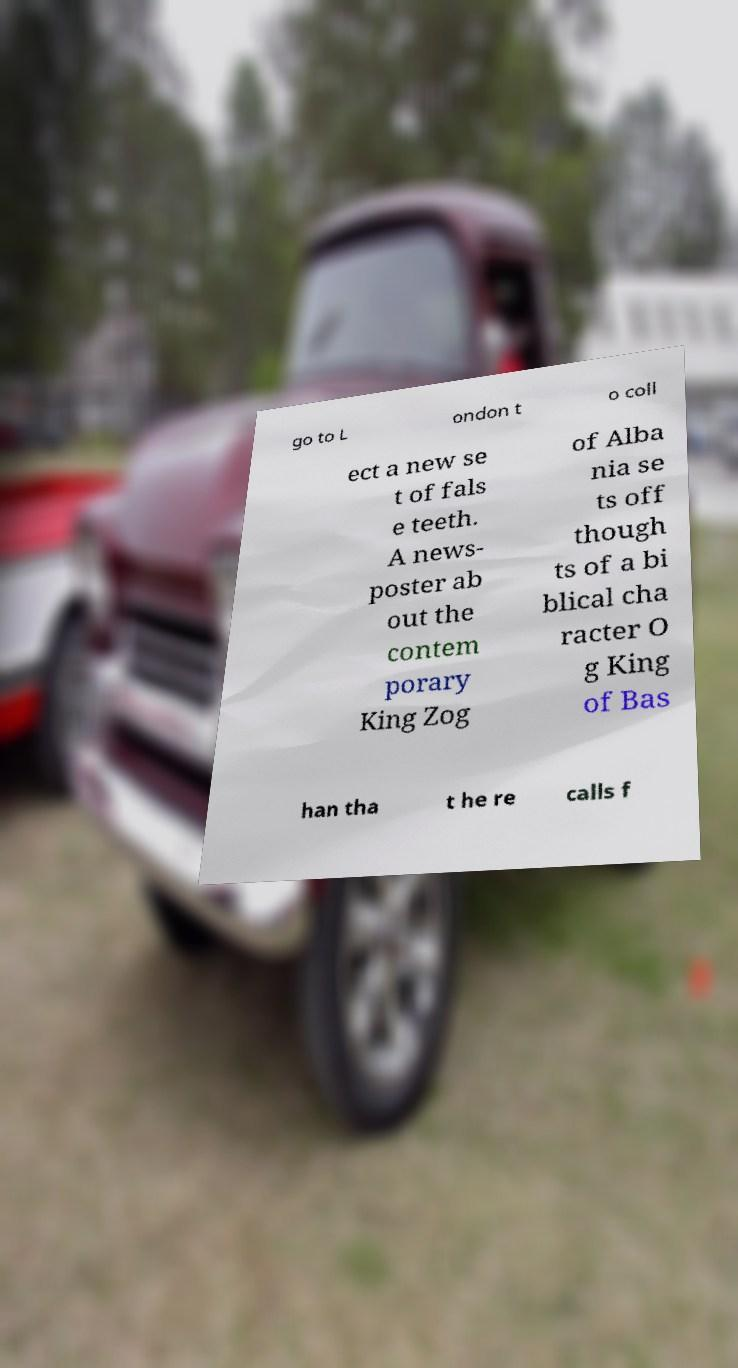Can you accurately transcribe the text from the provided image for me? go to L ondon t o coll ect a new se t of fals e teeth. A news- poster ab out the contem porary King Zog of Alba nia se ts off though ts of a bi blical cha racter O g King of Bas han tha t he re calls f 